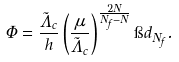Convert formula to latex. <formula><loc_0><loc_0><loc_500><loc_500>\Phi = \frac { \tilde { \Lambda } _ { c } } { h } \left ( \frac { \mu } { \tilde { \Lambda } _ { c } } \right ) ^ { \frac { 2 N } { N _ { f } - N } } \i d _ { N _ { f } } .</formula> 